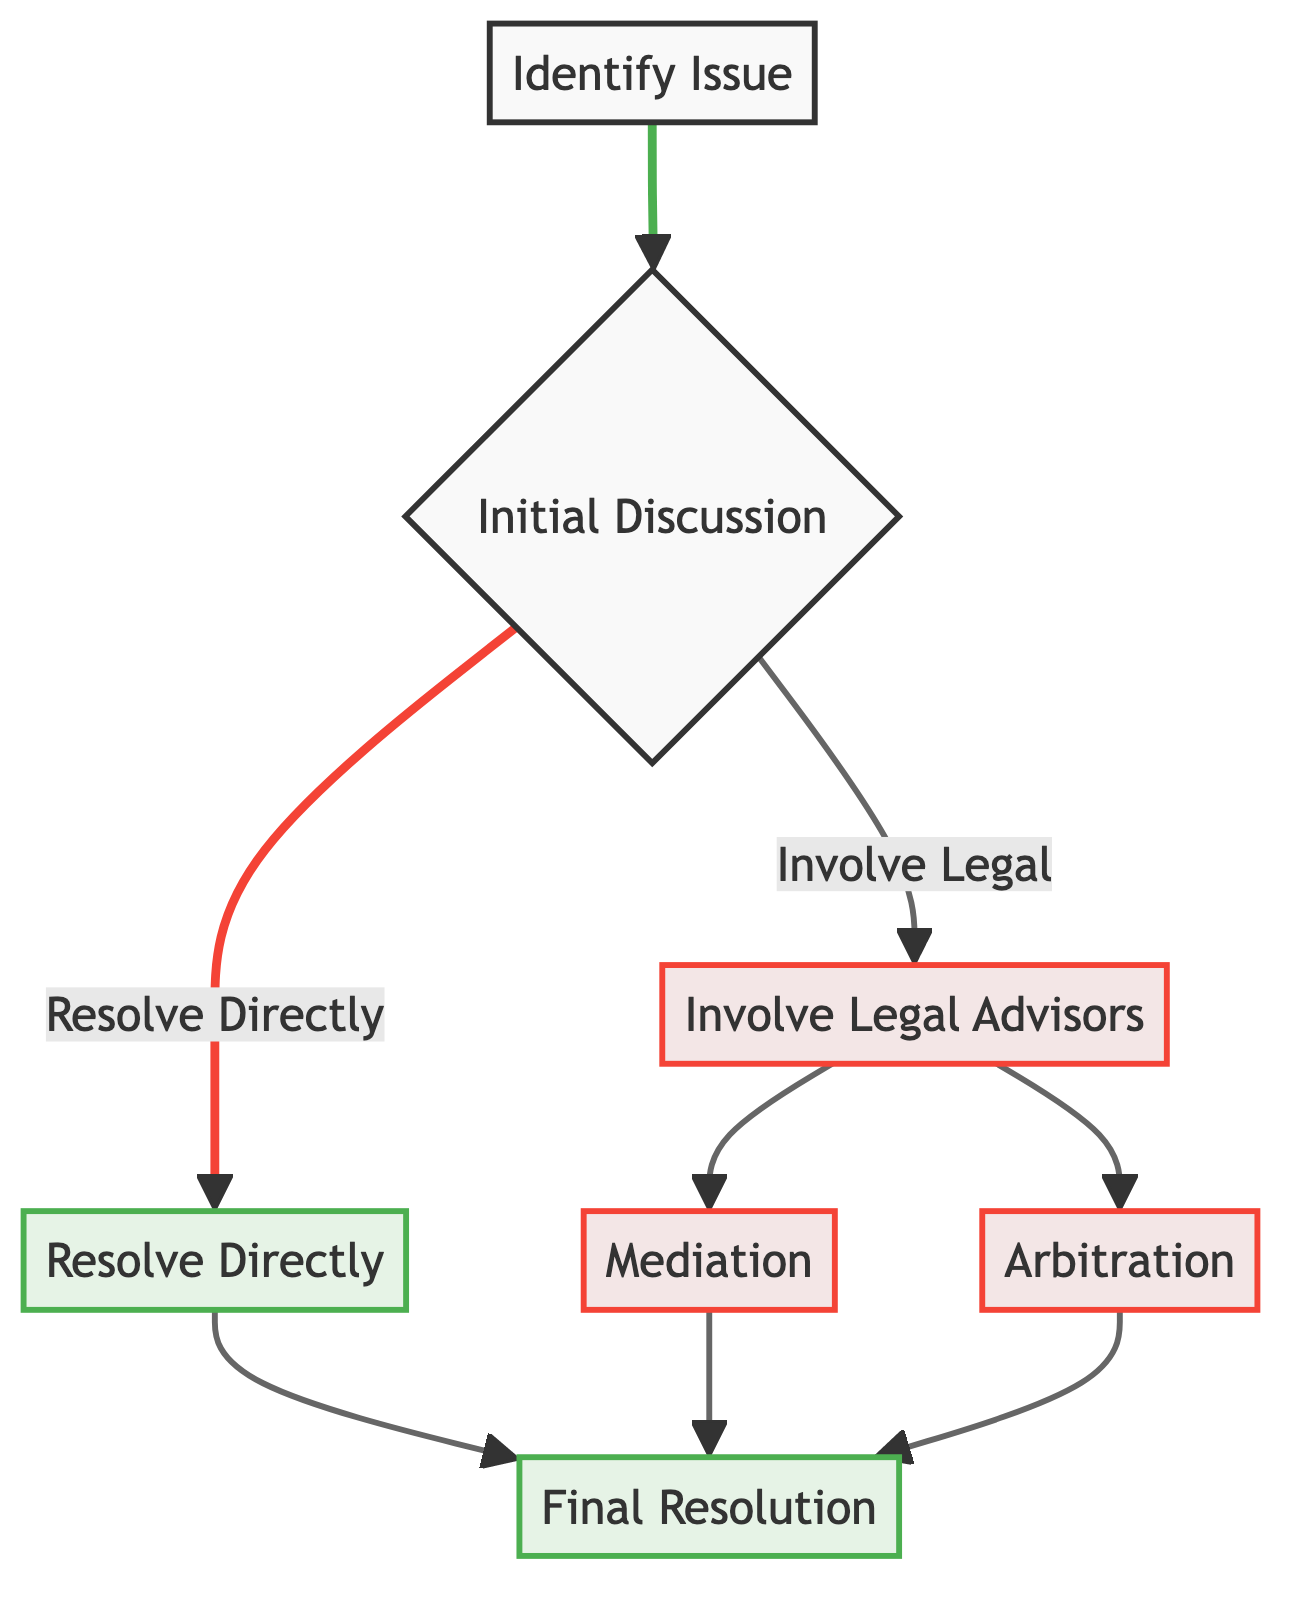What is the first step in resolving vendor disputes? The first step is "Identify Issue," where the specific issue or dispute with the vendor is recognized and documented.
Answer: Identify Issue How many possible actions can be taken after the initial discussion? After the initial discussion, there are two possible actions: "Resolve Directly" or "Involve Legal Advisors."
Answer: Two What action do you take if you choose to involve legal advisors? If you choose to involve legal advisors, the next steps are "Mediation" or "Arbitration."
Answer: Mediation or Arbitration What is the outcome of reaching a mutual agreement with the vendor? The outcome of reaching a mutual agreement is to implement the agreed-upon action or decision, leading to "Final Resolution."
Answer: Final Resolution What does the Mediation step entail? Mediation involves engaging a neutral third party to mediate between you and the vendor to find a mutually acceptable solution.
Answer: Engage a neutral third party If the dispute goes to Arbitration, what is the nature of the decision made? In Arbitration, a neutral arbitrator makes a binding decision on the dispute.
Answer: Binding decision What is the final resolution of the dispute called? The final resolution of the dispute is called "Final Resolution."
Answer: Final Resolution Which two paths can follow the step of involving legal advisors? The two paths are "Mediation" and "Arbitration."
Answer: Mediation and Arbitration What does the step "Resolve Directly" lead to? The step "Resolve Directly" leads to the "Final Resolution."
Answer: Final Resolution 